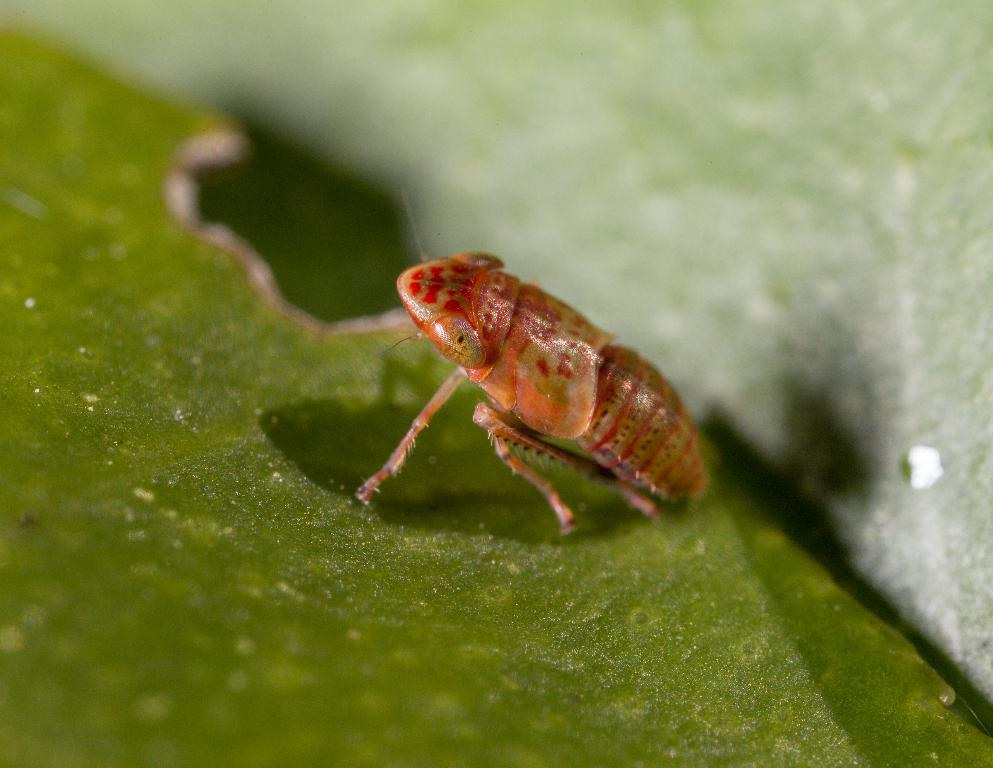What is present in the image? There is an insect in the image. Where is the insect located? The insect is on a leaf. Can you describe the background of the image? The background of the image is blurry. What type of pain is the insect experiencing in the image? There is no indication of pain in the image, as insects do not have the ability to express or experience pain in the same way humans do. 